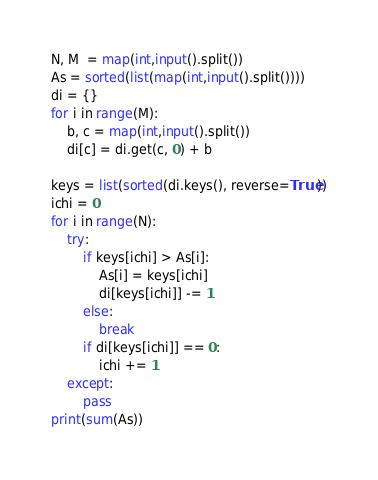Convert code to text. <code><loc_0><loc_0><loc_500><loc_500><_Python_>N, M  = map(int,input().split())
As = sorted(list(map(int,input().split())))
di = {}
for i in range(M):
    b, c = map(int,input().split())
    di[c] = di.get(c, 0) + b

keys = list(sorted(di.keys(), reverse=True))
ichi = 0
for i in range(N):
    try:
        if keys[ichi] > As[i]:
            As[i] = keys[ichi]
            di[keys[ichi]] -= 1
        else:
            break
        if di[keys[ichi]] == 0:
            ichi += 1
    except:
        pass
print(sum(As))
</code> 